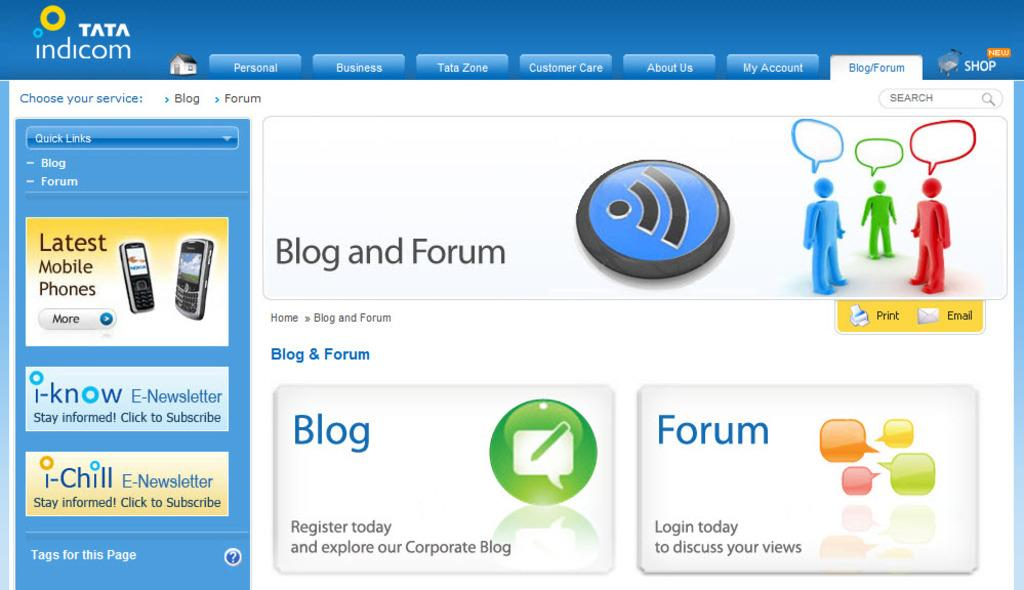What type of content is displayed in the image? The image is a web page. What can be seen on the web page that represents people? There are symbols of persons on the web page. What other image is present on the web page? There is an image of mobiles on the web page. Is there any text or data on the web page? Yes, there is some information on the web page. How many chairs are visible in the image? There are no chairs present in the image, as it is a web page and not a physical location. 